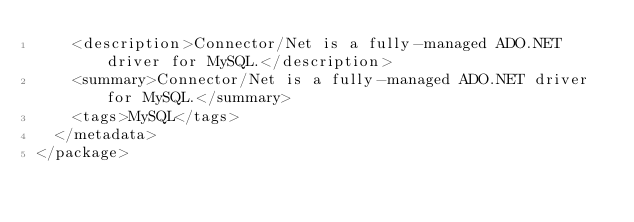<code> <loc_0><loc_0><loc_500><loc_500><_XML_>    <description>Connector/Net is a fully-managed ADO.NET driver for MySQL.</description>
    <summary>Connector/Net is a fully-managed ADO.NET driver for MySQL.</summary>
    <tags>MySQL</tags>
  </metadata>
</package></code> 